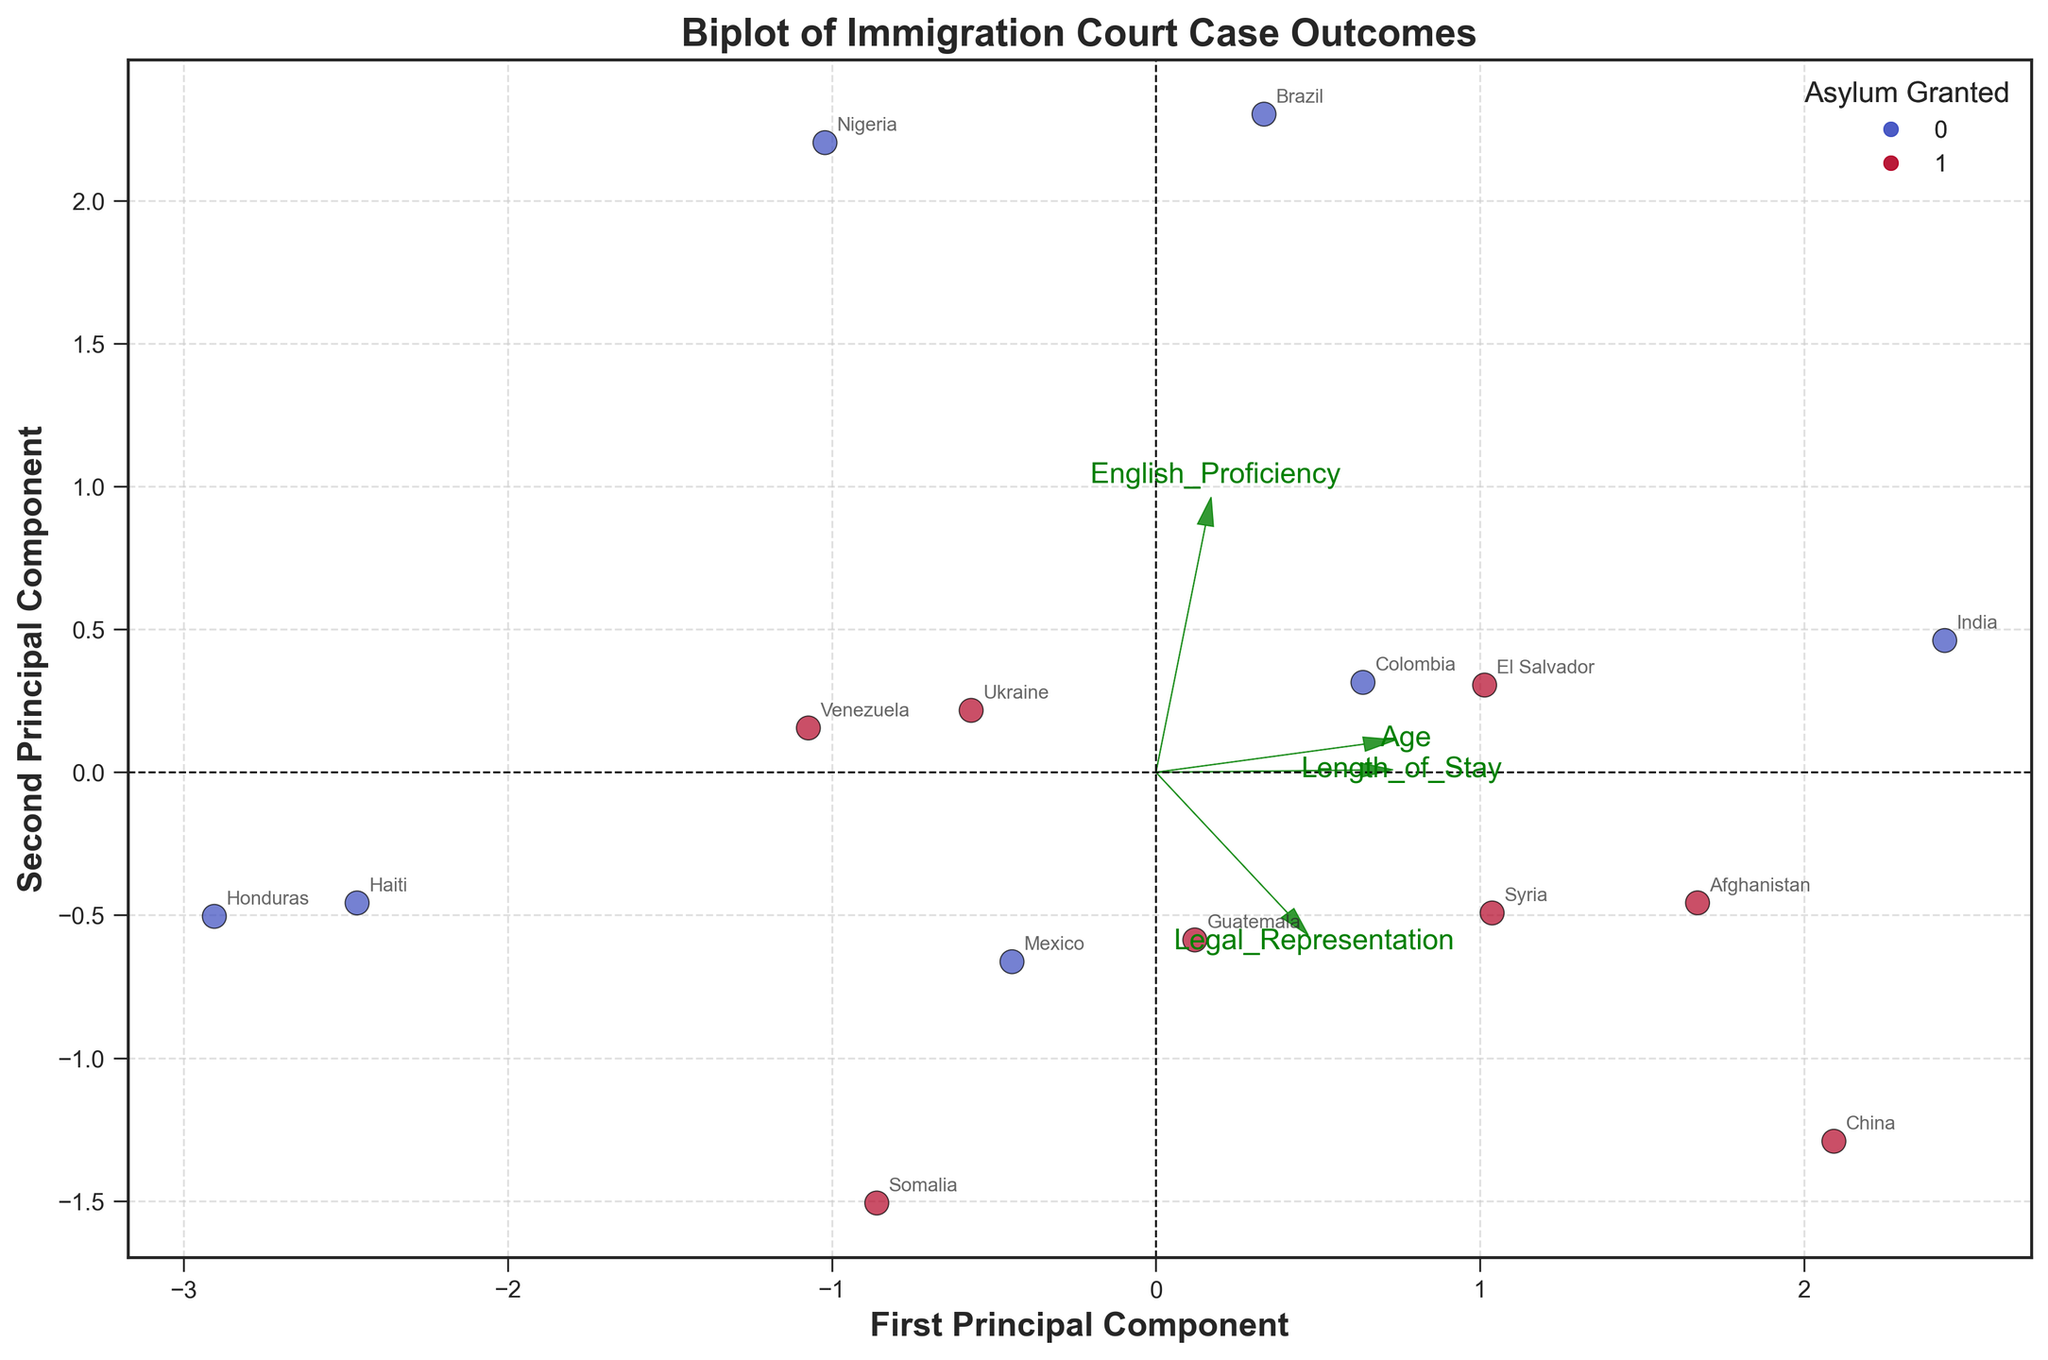How many data points are there in the plot? The scatter plot shows individual data points representing cases. By counting the number of labeled countries, we can determine the number of data points.
Answer: 15 What does the scatter point color indicate? The legend in the plot specifies that the colors represent whether asylum was granted. Specifically, red and blue colors differentiate between granted and not granted cases, respectively.
Answer: Asylum granted Which axis represents the first principal component? The plot labels its axes. The x-axis is labeled as the "First Principal Component" indicating it represents the first principal component.
Answer: x-axis What feature vectors are shown in the plot? The green arrows labeled with feature names such as "Age," "Length_of_Stay," "English_Proficiency," and "Legal_Representation" represent the feature vectors.
Answer: Age, Length_of_Stay, English_Proficiency, Legal_Representation Which country’s data point is most separated from the origin along the first principal component? By observing the data points along the x-axis (first principal component), we identify that India's point extends farthest from the origin.
Answer: India Are any data points overlapping in the plot? Observing the scatter plot, check for cases where points appear very close or overlap with each other visually. No such overlapping points are visible in this plot.
Answer: No Which feature vector aligns most closely with the first principal component? The arrow corresponding to "Length_of_Stay" most closely aligns with the x-axis, suggesting it has a significant loading in the first principal component.
Answer: Length_of_Stay Does legal representation correlate more strongly with the first or second principal component? The "Legal_Representation" arrow points more in the direction of the y-axis (second principal component), indicating it correlates more with the second principal component.
Answer: Second Do females generally have their asylum granted more frequently based on the plot? By noting the scatter points and cross-referencing them with gender labels on the plot, many red points (asylum granted) correspond to female data points.
Answer: Yes Is there any indication that country of origin affects the decision on asylum granted? Observing scatter points from different countries, we notice varied outcomes, suggesting multiple factors beyond country of origin affect the decision, with no single country dominating either outcome.
Answer: No consistent pattern 